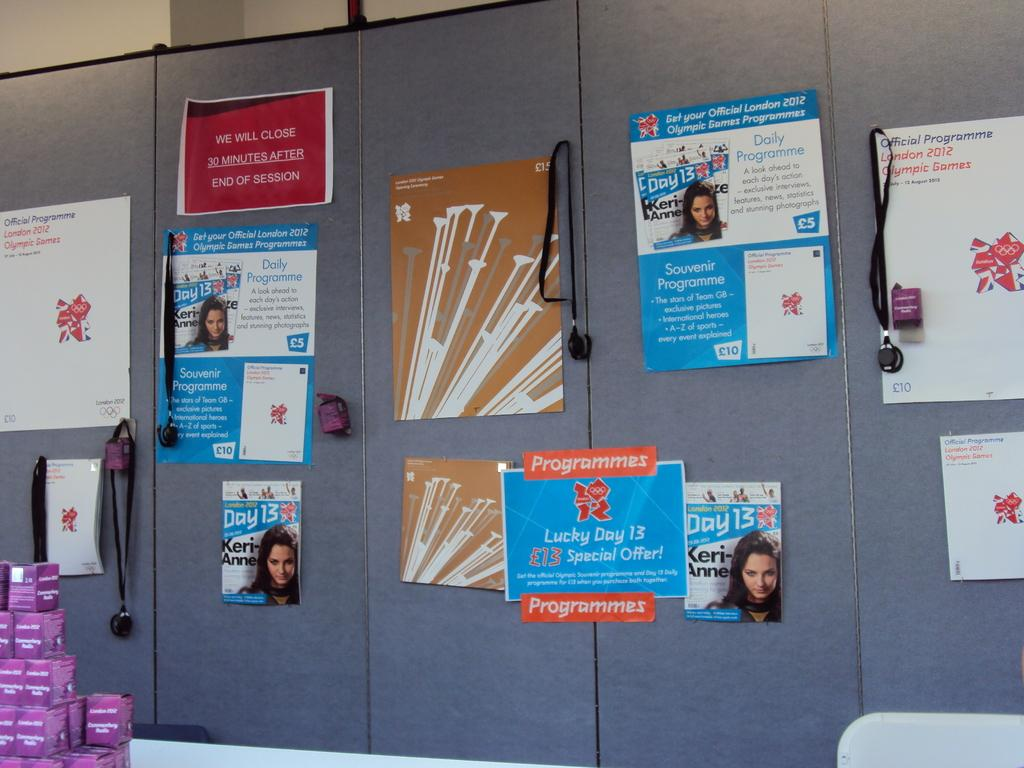Provide a one-sentence caption for the provided image. Cabinets with pictures from magazines with Keri Anne. 